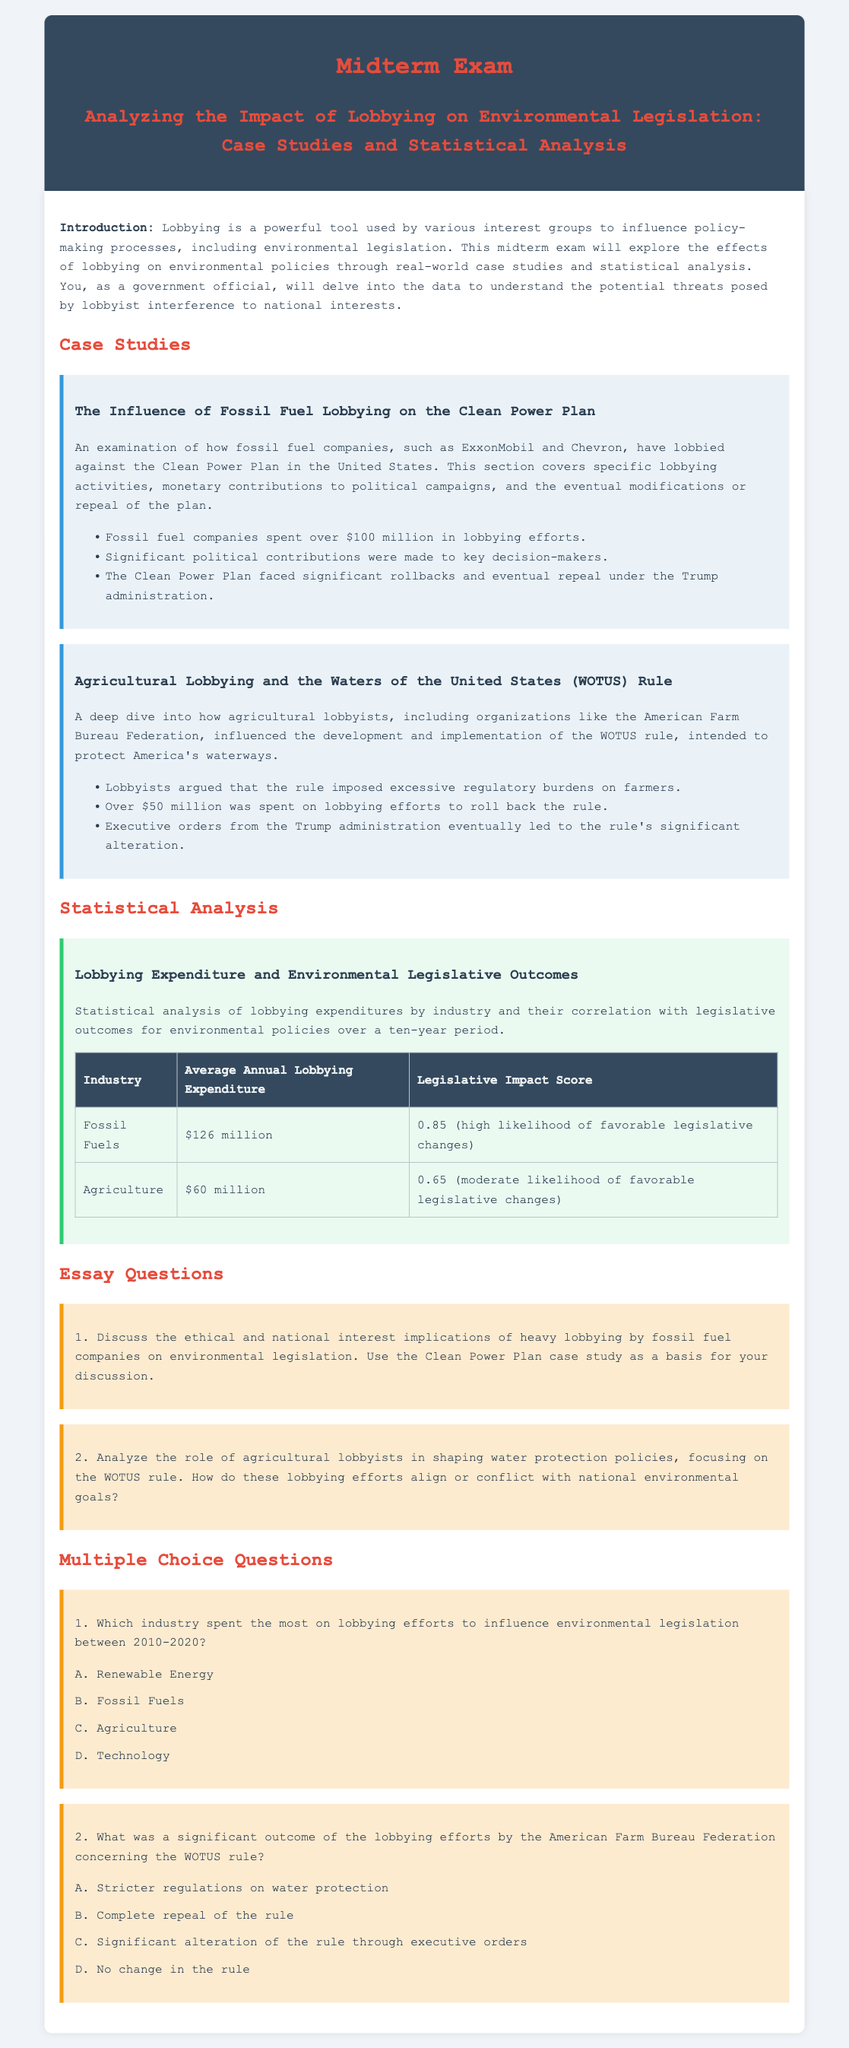What industry spent over $100 million on lobbying efforts? The document states that fossil fuel companies spent over $100 million in lobbying efforts against the Clean Power Plan.
Answer: Fossil Fuels How much did agricultural lobbyists spend on lobbying to roll back the WOTUS rule? According to the document, agricultural lobbyists spent over $50 million on lobbying efforts to roll back the WOTUS rule.
Answer: $50 million What was the average annual lobbying expenditure for the fossil fuel industry? The statistical analysis table shows that the average annual lobbying expenditure for fossil fuels was $126 million.
Answer: $126 million What legislative impact score is associated with the agriculture industry? The table in the document indicates that the legislative impact score for the agriculture industry is 0.65.
Answer: 0.65 What was a significant outcome of the fossil fuel lobbying efforts on the Clean Power Plan? The document states that the Clean Power Plan faced significant rollbacks and eventual repeal under the Trump administration.
Answer: Rollbacks and repeal What ethical considerations arise from lobbying by fossil fuel companies? The ethical implications discussed pertain to the potential interests being prioritized over national interests, particularly regarding the Clean Power Plan.
Answer: National interests List one organization that heavily influenced the development of the WOTUS rule. The document cites the American Farm Bureau Federation as a key organization that influenced the WOTUS rule.
Answer: American Farm Bureau Federation What did lobbyists claim regarding the WOTUS rule? The document notes that lobbyists argued the rule imposed excessive regulatory burdens on farmers.
Answer: Excessive regulatory burdens How does the document categorize the likelihood of favorable legislative changes for the fossil fuel industry? The document provides a legislative impact score of 0.85 for the fossil fuel industry, indicating a high likelihood of favorable changes.
Answer: High likelihood 